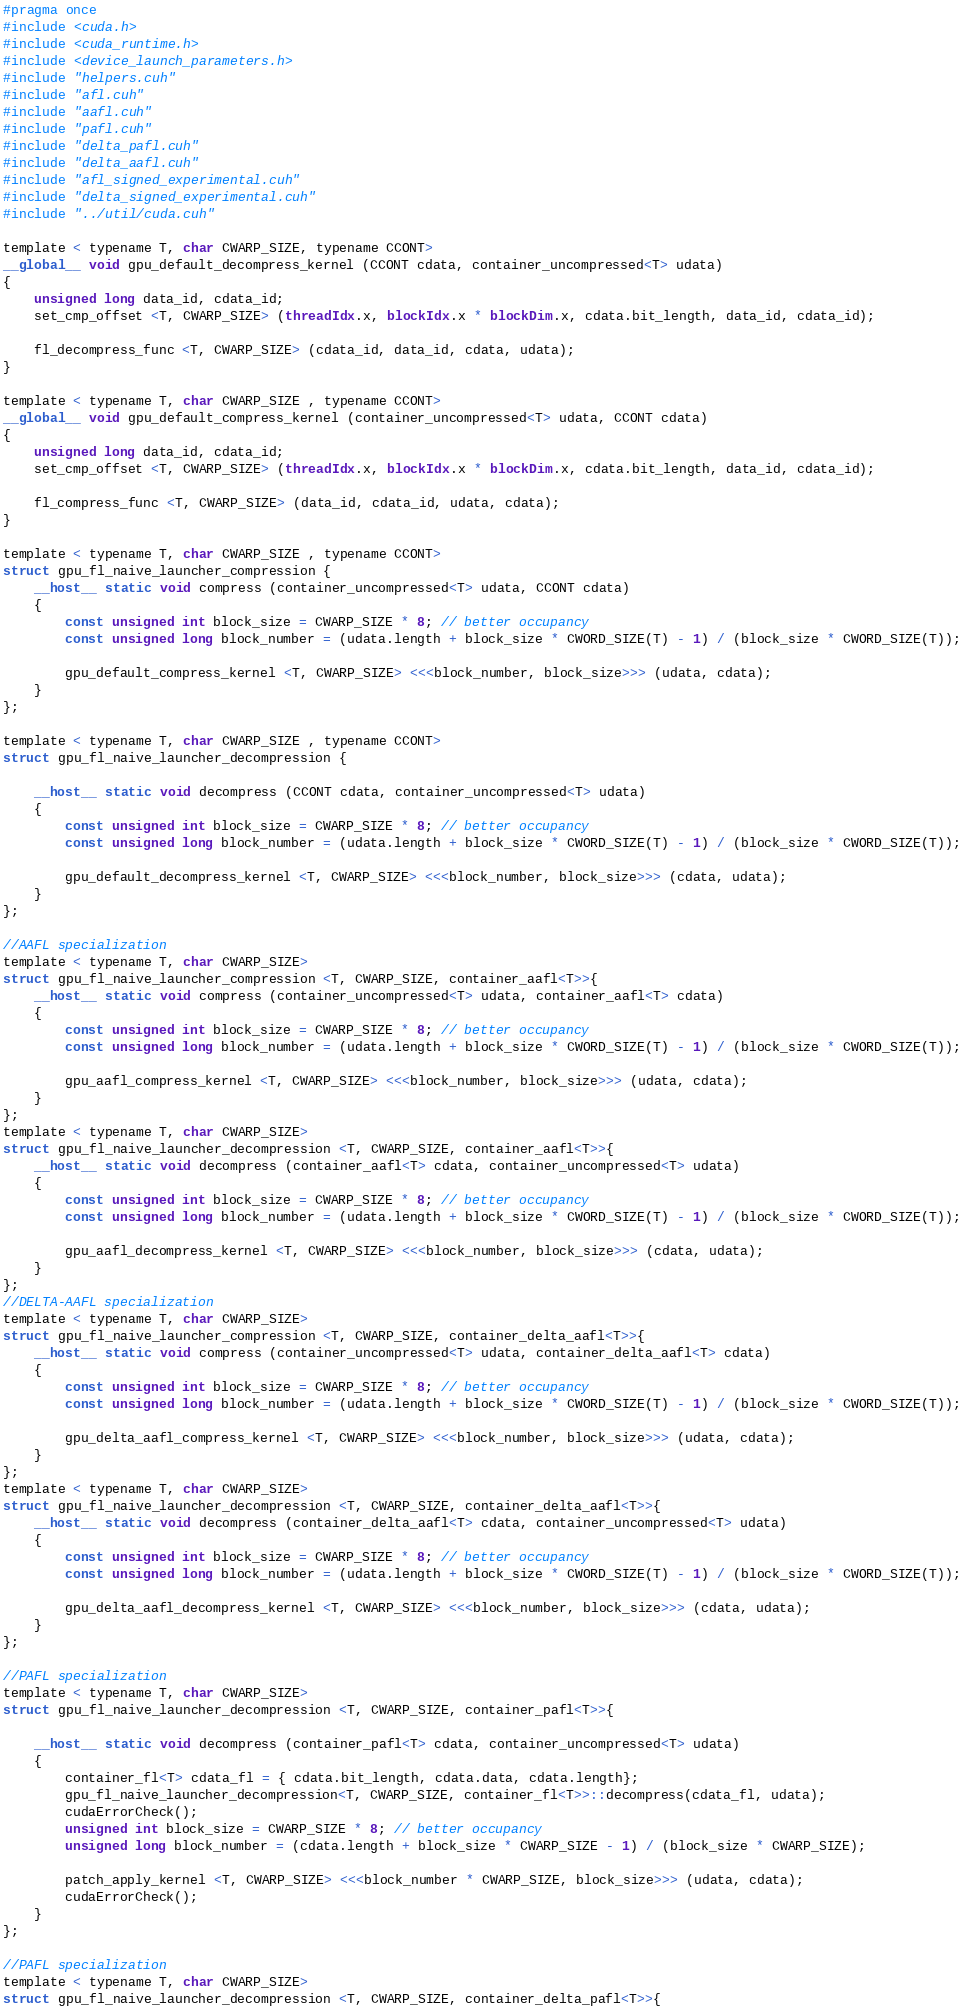Convert code to text. <code><loc_0><loc_0><loc_500><loc_500><_Cuda_>#pragma once
#include <cuda.h>
#include <cuda_runtime.h>
#include <device_launch_parameters.h>
#include "helpers.cuh"
#include "afl.cuh"
#include "aafl.cuh"
#include "pafl.cuh"
#include "delta_pafl.cuh"
#include "delta_aafl.cuh"
#include "afl_signed_experimental.cuh"
#include "delta_signed_experimental.cuh"
#include "../util/cuda.cuh"

template < typename T, char CWARP_SIZE, typename CCONT>
__global__ void gpu_default_decompress_kernel (CCONT cdata, container_uncompressed<T> udata)
{
    unsigned long data_id, cdata_id;
    set_cmp_offset <T, CWARP_SIZE> (threadIdx.x, blockIdx.x * blockDim.x, cdata.bit_length, data_id, cdata_id);

    fl_decompress_func <T, CWARP_SIZE> (cdata_id, data_id, cdata, udata);
}

template < typename T, char CWARP_SIZE , typename CCONT>
__global__ void gpu_default_compress_kernel (container_uncompressed<T> udata, CCONT cdata)
{
    unsigned long data_id, cdata_id;
    set_cmp_offset <T, CWARP_SIZE> (threadIdx.x, blockIdx.x * blockDim.x, cdata.bit_length, data_id, cdata_id);

    fl_compress_func <T, CWARP_SIZE> (data_id, cdata_id, udata, cdata);
}

template < typename T, char CWARP_SIZE , typename CCONT>
struct gpu_fl_naive_launcher_compression {
    __host__ static void compress (container_uncompressed<T> udata, CCONT cdata)
    {
        const unsigned int block_size = CWARP_SIZE * 8; // better occupancy
        const unsigned long block_number = (udata.length + block_size * CWORD_SIZE(T) - 1) / (block_size * CWORD_SIZE(T));

        gpu_default_compress_kernel <T, CWARP_SIZE> <<<block_number, block_size>>> (udata, cdata);
    }
};

template < typename T, char CWARP_SIZE , typename CCONT>
struct gpu_fl_naive_launcher_decompression {

    __host__ static void decompress (CCONT cdata, container_uncompressed<T> udata)
    {
        const unsigned int block_size = CWARP_SIZE * 8; // better occupancy
        const unsigned long block_number = (udata.length + block_size * CWORD_SIZE(T) - 1) / (block_size * CWORD_SIZE(T));

        gpu_default_decompress_kernel <T, CWARP_SIZE> <<<block_number, block_size>>> (cdata, udata);
    }
};

//AAFL specialization
template < typename T, char CWARP_SIZE>
struct gpu_fl_naive_launcher_compression <T, CWARP_SIZE, container_aafl<T>>{
    __host__ static void compress (container_uncompressed<T> udata, container_aafl<T> cdata)
    {
        const unsigned int block_size = CWARP_SIZE * 8; // better occupancy
        const unsigned long block_number = (udata.length + block_size * CWORD_SIZE(T) - 1) / (block_size * CWORD_SIZE(T));

        gpu_aafl_compress_kernel <T, CWARP_SIZE> <<<block_number, block_size>>> (udata, cdata);
    }
};
template < typename T, char CWARP_SIZE>
struct gpu_fl_naive_launcher_decompression <T, CWARP_SIZE, container_aafl<T>>{
    __host__ static void decompress (container_aafl<T> cdata, container_uncompressed<T> udata)
    {
        const unsigned int block_size = CWARP_SIZE * 8; // better occupancy
        const unsigned long block_number = (udata.length + block_size * CWORD_SIZE(T) - 1) / (block_size * CWORD_SIZE(T));

        gpu_aafl_decompress_kernel <T, CWARP_SIZE> <<<block_number, block_size>>> (cdata, udata);
    }
};
//DELTA-AAFL specialization
template < typename T, char CWARP_SIZE>
struct gpu_fl_naive_launcher_compression <T, CWARP_SIZE, container_delta_aafl<T>>{
    __host__ static void compress (container_uncompressed<T> udata, container_delta_aafl<T> cdata)
    {
        const unsigned int block_size = CWARP_SIZE * 8; // better occupancy
        const unsigned long block_number = (udata.length + block_size * CWORD_SIZE(T) - 1) / (block_size * CWORD_SIZE(T));

        gpu_delta_aafl_compress_kernel <T, CWARP_SIZE> <<<block_number, block_size>>> (udata, cdata);
    }
};
template < typename T, char CWARP_SIZE>
struct gpu_fl_naive_launcher_decompression <T, CWARP_SIZE, container_delta_aafl<T>>{
    __host__ static void decompress (container_delta_aafl<T> cdata, container_uncompressed<T> udata)
    {
        const unsigned int block_size = CWARP_SIZE * 8; // better occupancy
        const unsigned long block_number = (udata.length + block_size * CWORD_SIZE(T) - 1) / (block_size * CWORD_SIZE(T));

        gpu_delta_aafl_decompress_kernel <T, CWARP_SIZE> <<<block_number, block_size>>> (cdata, udata);
    }
};

//PAFL specialization
template < typename T, char CWARP_SIZE>
struct gpu_fl_naive_launcher_decompression <T, CWARP_SIZE, container_pafl<T>>{

    __host__ static void decompress (container_pafl<T> cdata, container_uncompressed<T> udata)
    {
        container_fl<T> cdata_fl = { cdata.bit_length, cdata.data, cdata.length};
        gpu_fl_naive_launcher_decompression<T, CWARP_SIZE, container_fl<T>>::decompress(cdata_fl, udata);
        cudaErrorCheck();
        unsigned int block_size = CWARP_SIZE * 8; // better occupancy
        unsigned long block_number = (cdata.length + block_size * CWARP_SIZE - 1) / (block_size * CWARP_SIZE);

        patch_apply_kernel <T, CWARP_SIZE> <<<block_number * CWARP_SIZE, block_size>>> (udata, cdata);
        cudaErrorCheck();
    }
};

//PAFL specialization
template < typename T, char CWARP_SIZE>
struct gpu_fl_naive_launcher_decompression <T, CWARP_SIZE, container_delta_pafl<T>>{
</code> 